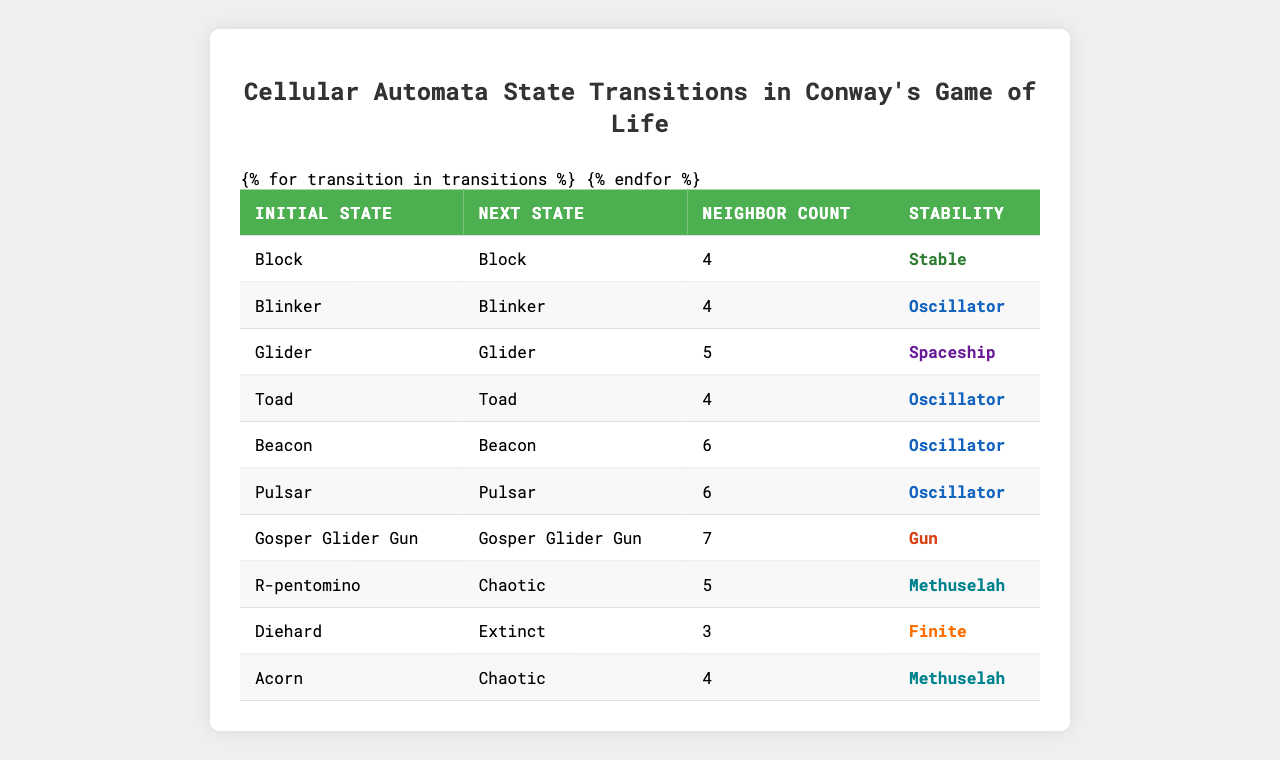What is the stability of the "Blinker" state? In the table, look for the entry with "Blinker" as the initial state, and check the corresponding stability value. The table states that the stability of the "Blinker" is "Oscillator."
Answer: Oscillator How many neighbor cells does the "Gosper Glider Gun" have? Locate the row where the initial state is "Gosper Glider Gun," then read the number of neighbor cells from the same row, which indicates it has 7 neighbor cells.
Answer: 7 Which states have a stability classified as "Methuselah"? Check the stability column for entries marked as "Methuselah." The states listed are "R-pentomino" and "Acorn."
Answer: R-pentomino, Acorn What is the next state if the initial state is "Toad"? Find the row for "Toad" in the initial state column and read the value in the next state column, which shows that "Toad" transitions to "Toad."
Answer: Toad Which initial state has the highest neighbor count? Review the neighbor count values from all entries. The highest value found is 7 neighbors for the "Gosper Glider Gun." Therefore, the state with the highest neighbor count is "Gosper Glider Gun."
Answer: Gosper Glider Gun How many states are categorized as "Oscillator"? Count the entries in the stability column that are marked as "Oscillator." The states "Blinker," "Toad," "Beacon," and "Pulsar" make a total of four.
Answer: 4 Does the "Diehard" state lead to a stable next state? Look at the transition for "Diehard," which shows that it leads to "Extinct" with a stability classification of "Finite." Since finite states can be considered non-stable in the long term, the answer is no.
Answer: No What is the relationship between the "R-pentomino" and "Acorn" states regarding their next state? Both "R-pentomino" and "Acorn" have a next state of "Chaotic," indicating they both lead to a chaotic state after their initial configurations.
Answer: Chaotic Among the states, which has the fewest neighbors and what is its stability type? Look for the lowest neighbor count in the table. "Diehard" has the fewest neighbors with a count of 3, and its stability is classified as "Finite."
Answer: Diehard, Finite What can be concluded about the stability of the "Glider"? The table shows that the "Glider" has a stability classified as "Spaceship," indicating that it moves in space and does not remain static or stable in one location.
Answer: Spaceship 